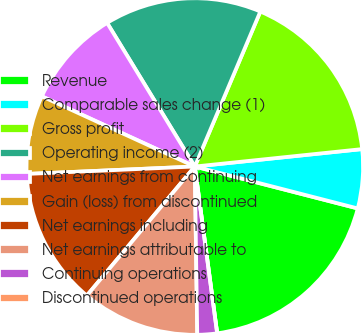Convert chart. <chart><loc_0><loc_0><loc_500><loc_500><pie_chart><fcel>Revenue<fcel>Comparable sales change (1)<fcel>Gross profit<fcel>Operating income (2)<fcel>Net earnings from continuing<fcel>Gain (loss) from discontinued<fcel>Net earnings including<fcel>Net earnings attributable to<fcel>Continuing operations<fcel>Discontinued operations<nl><fcel>18.87%<fcel>5.66%<fcel>16.98%<fcel>15.09%<fcel>9.43%<fcel>7.55%<fcel>13.21%<fcel>11.32%<fcel>1.89%<fcel>0.0%<nl></chart> 